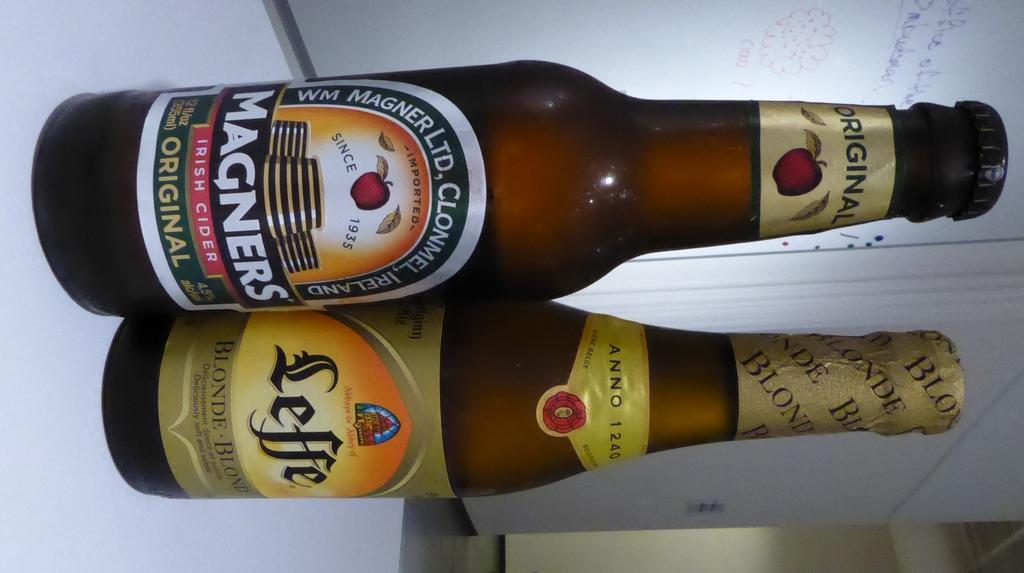<image>
Provide a brief description of the given image. A Magners bottle sitting next to another bottle 